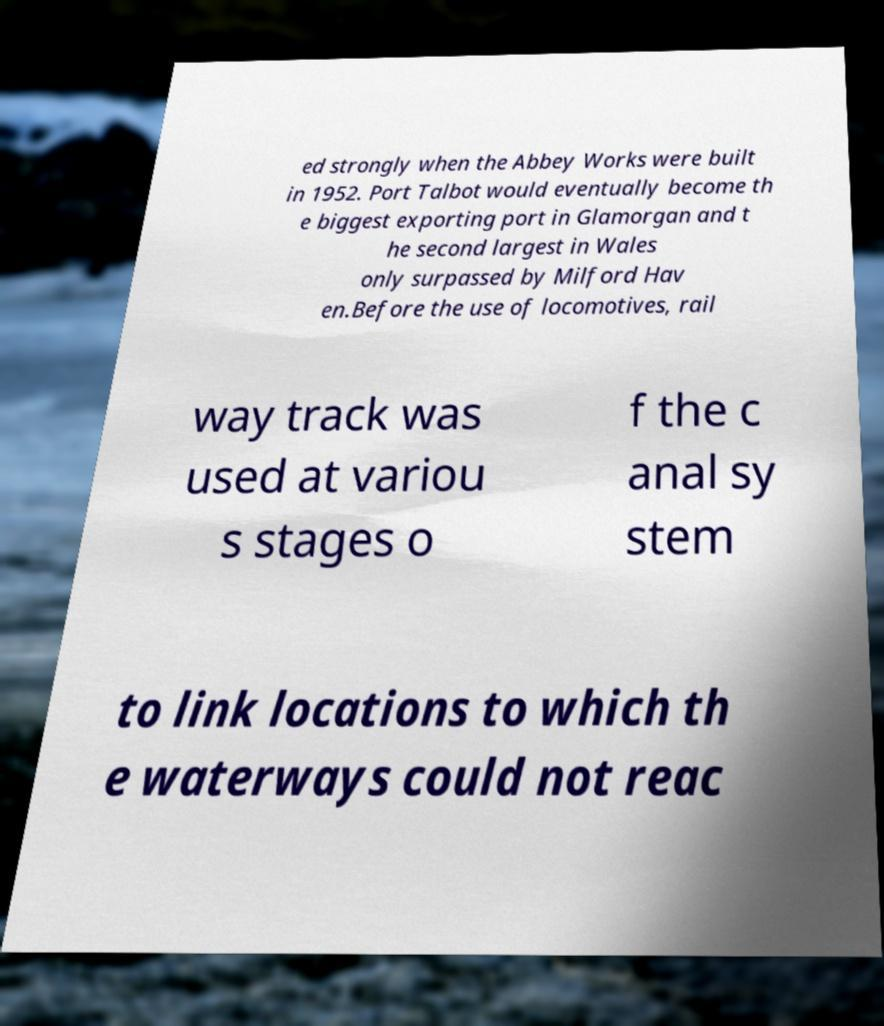Please identify and transcribe the text found in this image. ed strongly when the Abbey Works were built in 1952. Port Talbot would eventually become th e biggest exporting port in Glamorgan and t he second largest in Wales only surpassed by Milford Hav en.Before the use of locomotives, rail way track was used at variou s stages o f the c anal sy stem to link locations to which th e waterways could not reac 